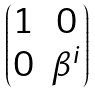<formula> <loc_0><loc_0><loc_500><loc_500>\begin{pmatrix} 1 & 0 \\ 0 & \beta ^ { i } \end{pmatrix}</formula> 